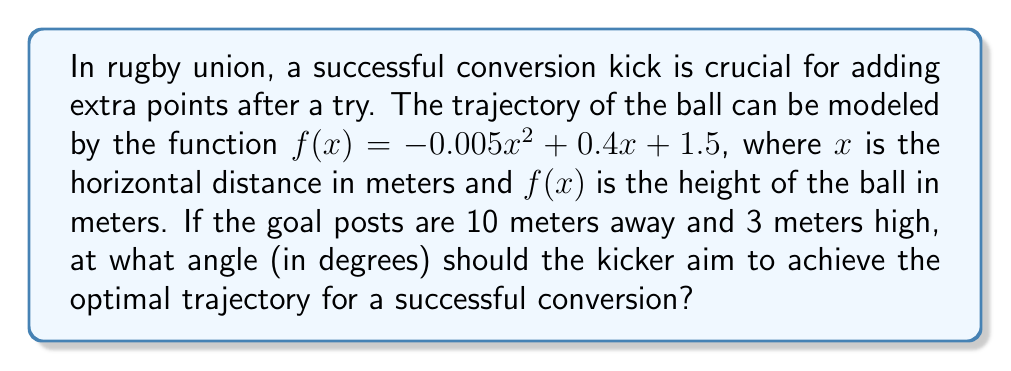Can you answer this question? Let's approach this step-by-step:

1) First, we need to find the point where the ball passes through the plane of the goal posts. This occurs when $x = 10$ (as the posts are 10 meters away).

2) At this point, the height of the ball is:
   $f(10) = -0.005(10)^2 + 0.4(10) + 1.5$
   $= -0.5 + 4 + 1.5 = 5$ meters

3) Now we have two points: the kicker's position $(0, 1.5)$ and the ball's position at the goal posts $(10, 5)$.

4) To find the angle, we can use the arctangent function:
   $\theta = \arctan(\frac{\text{rise}}{\text{run}})$

5) Rise = $5 - 1.5 = 3.5$ meters
   Run = $10$ meters

6) Therefore:
   $\theta = \arctan(\frac{3.5}{10})$

7) Converting to degrees:
   $\theta = \arctan(\frac{3.5}{10}) \cdot \frac{180}{\pi} \approx 19.29°$
Answer: $19.29°$ 